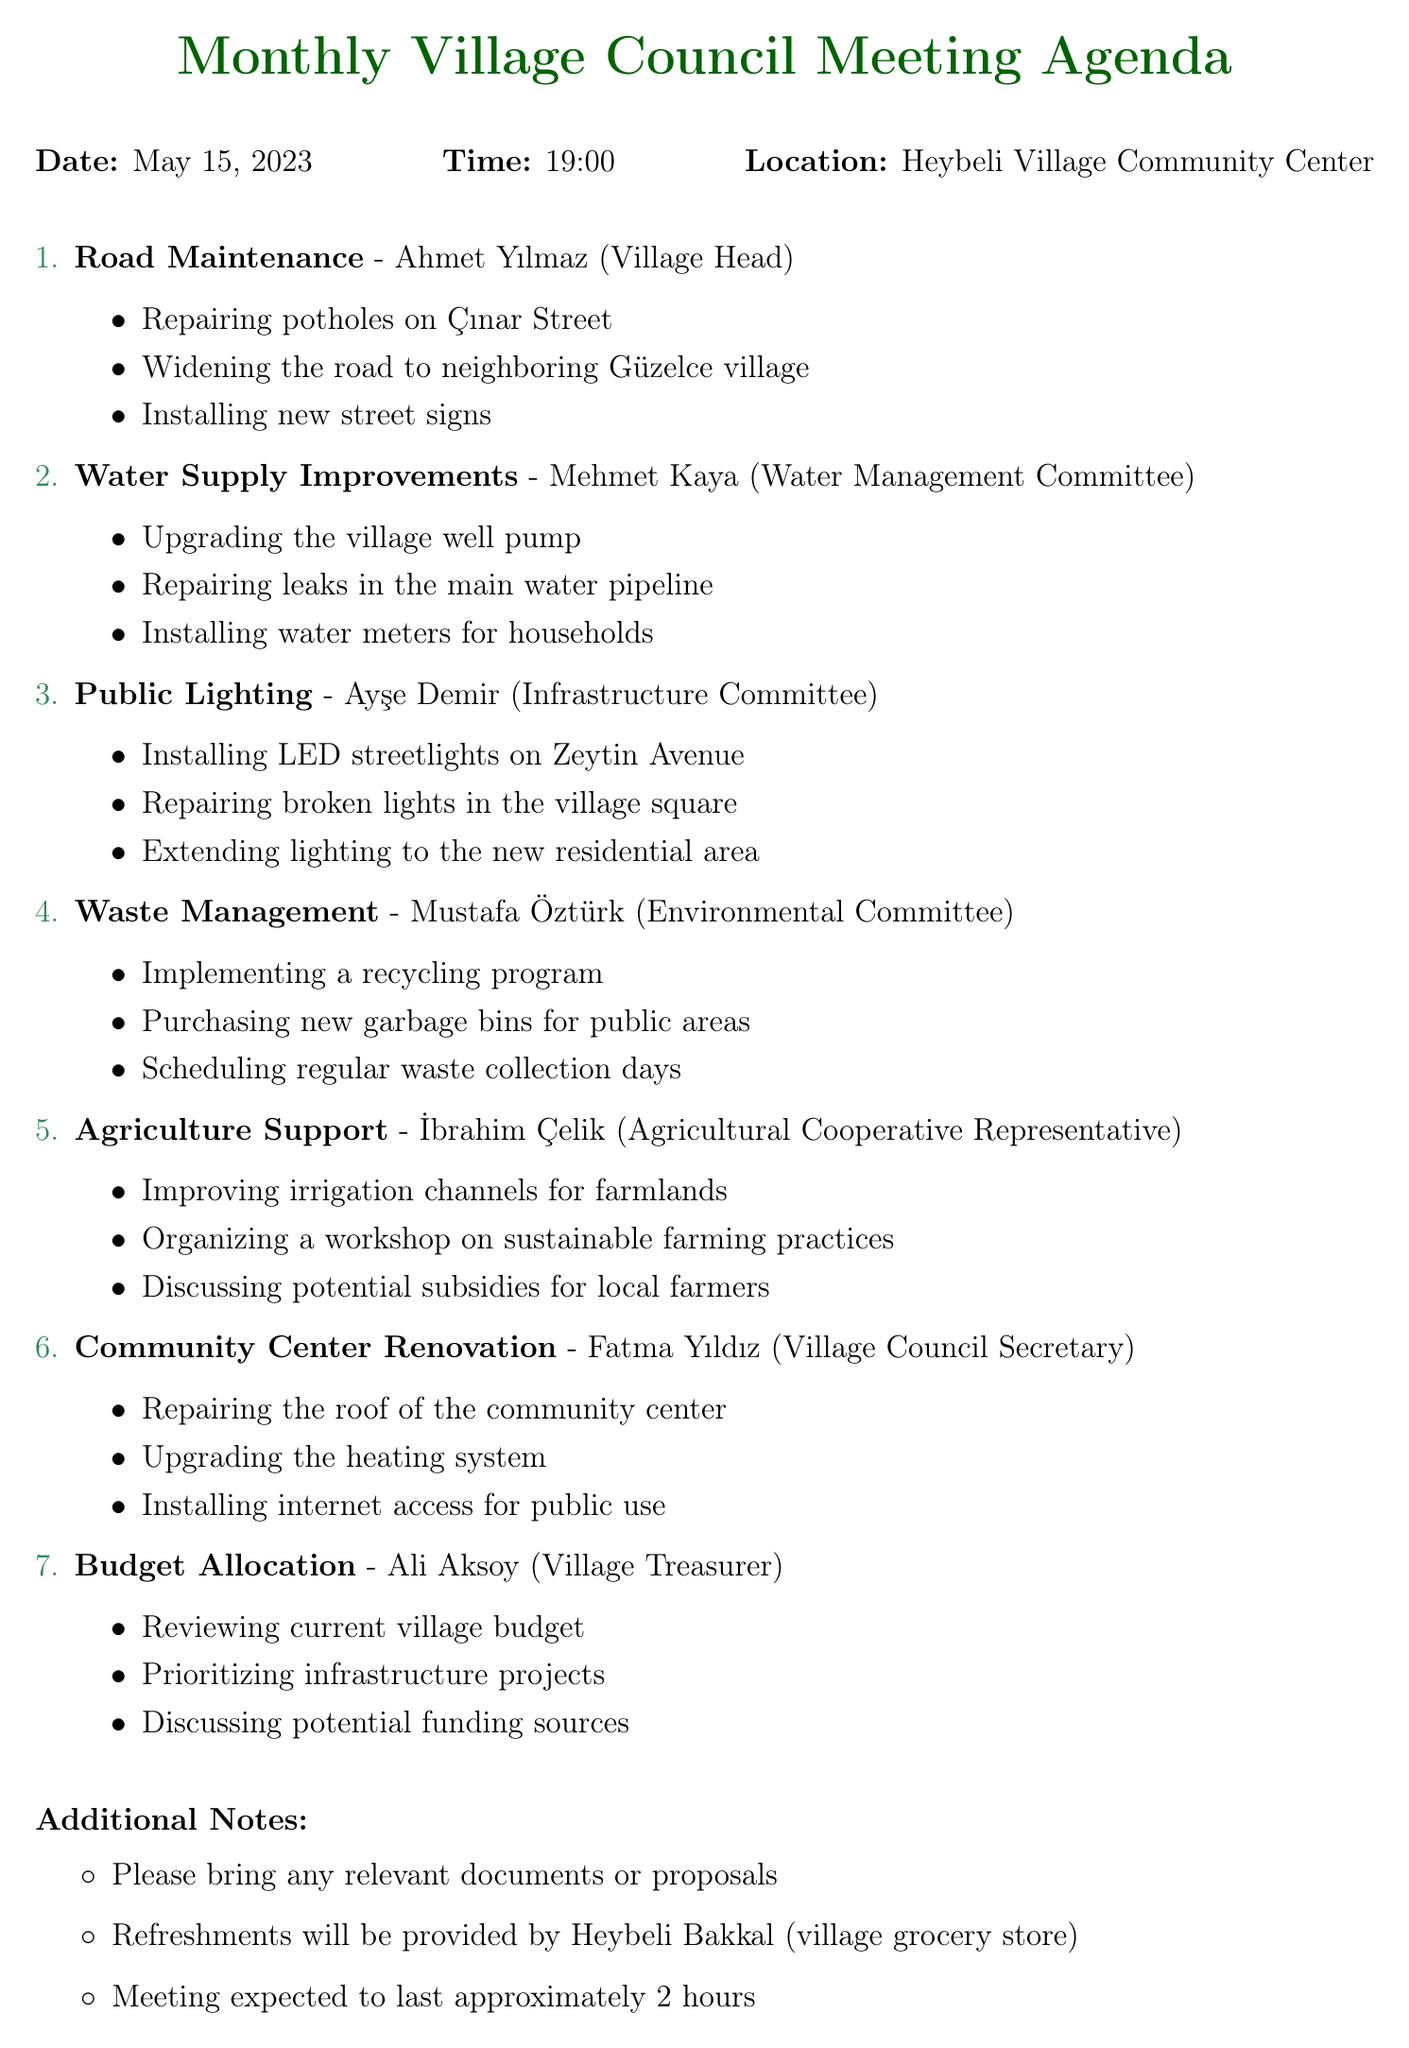What date is the meeting scheduled for? The meeting is scheduled for May 15, 2023, as indicated in the document.
Answer: May 15, 2023 Who is responsible for road maintenance? The person responsible for road maintenance is mentioned in the agenda item for that topic.
Answer: Ahmet Yılmaz Which committee is tasked with water supply improvements? The agenda item specifies the responsible committee for water supply improvements.
Answer: Water Management Committee How many agenda items are listed? The total number of agenda items can be counted from the document, which lists each item clearly.
Answer: Seven What is one topic discussed under waste management? The subtopics under waste management are listed, and we can mention any one of them.
Answer: Implementing a recycling program Who is responsible for budget allocation? The document specifies who is responsible for the budget allocation topic.
Answer: Ali Aksoy What will be provided by the village grocery store? The document notes what will be provided during the meeting.
Answer: Refreshments How long is the meeting expected to last? The document provides an estimation of the meeting duration.
Answer: Approximately 2 hours 